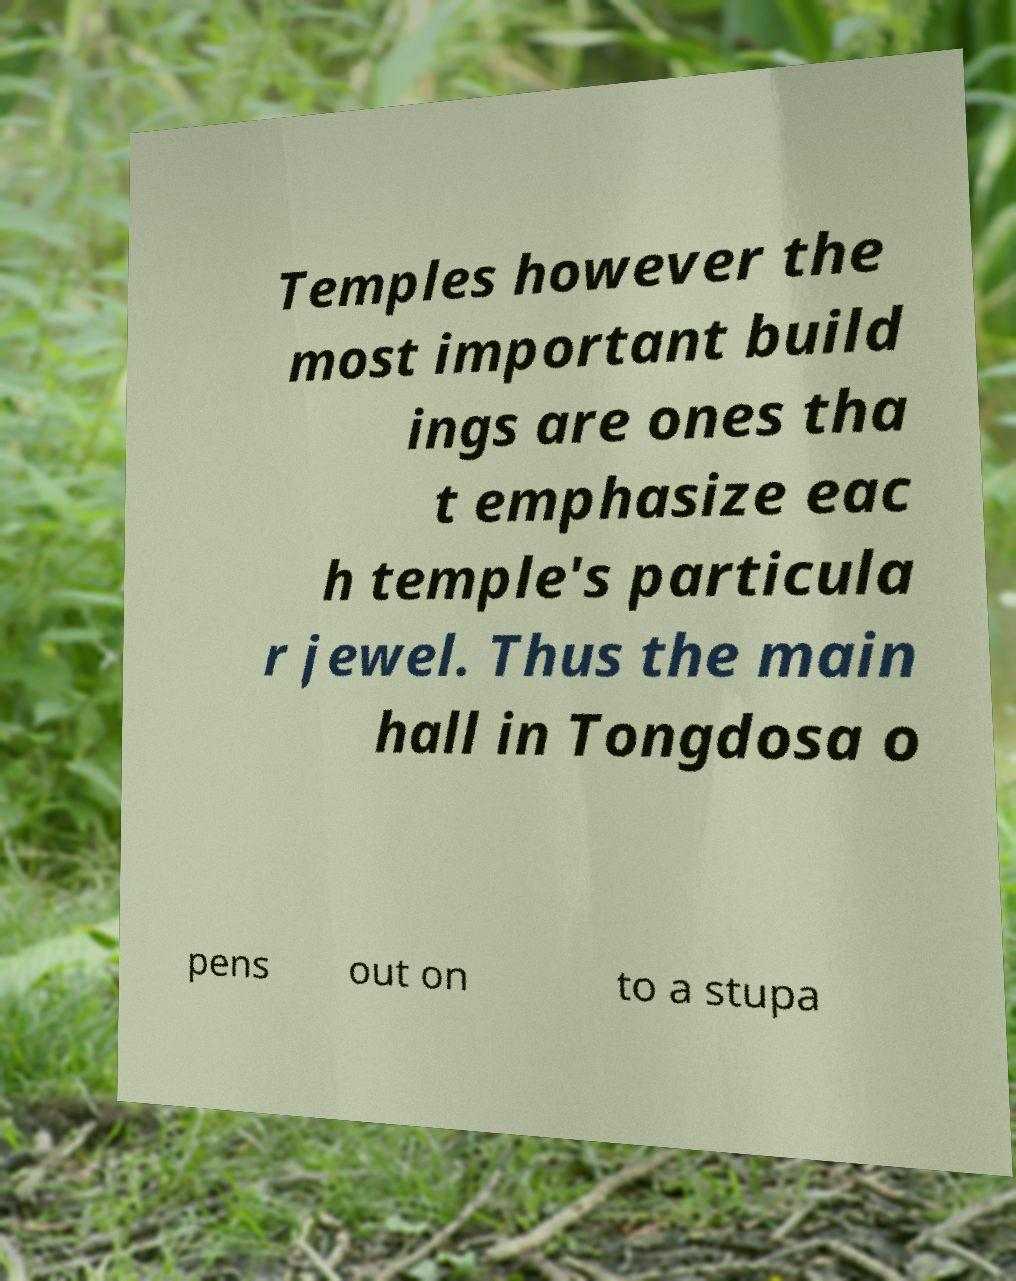What messages or text are displayed in this image? I need them in a readable, typed format. Temples however the most important build ings are ones tha t emphasize eac h temple's particula r jewel. Thus the main hall in Tongdosa o pens out on to a stupa 